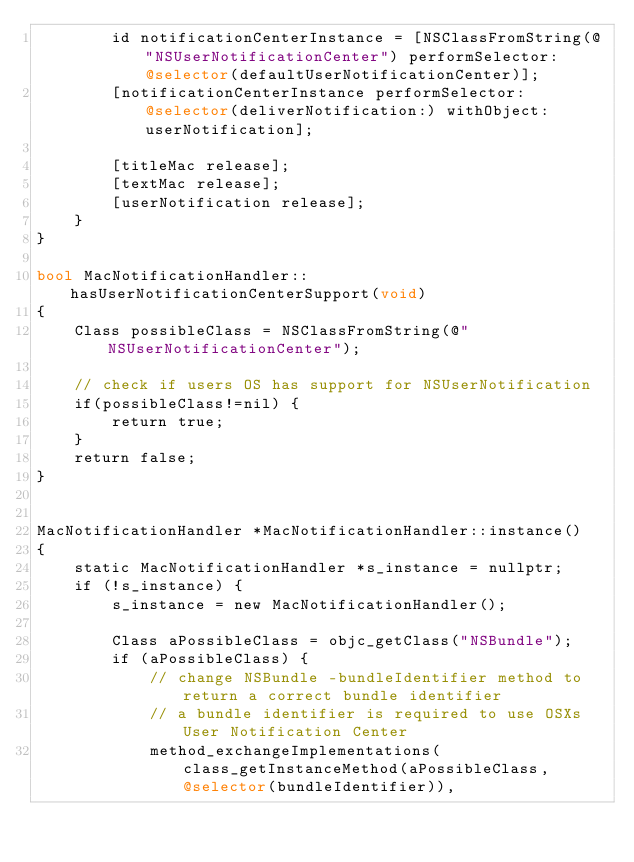Convert code to text. <code><loc_0><loc_0><loc_500><loc_500><_ObjectiveC_>        id notificationCenterInstance = [NSClassFromString(@"NSUserNotificationCenter") performSelector:@selector(defaultUserNotificationCenter)];
        [notificationCenterInstance performSelector:@selector(deliverNotification:) withObject:userNotification];

        [titleMac release];
        [textMac release];
        [userNotification release];
    }
}

bool MacNotificationHandler::hasUserNotificationCenterSupport(void)
{
    Class possibleClass = NSClassFromString(@"NSUserNotificationCenter");

    // check if users OS has support for NSUserNotification
    if(possibleClass!=nil) {
        return true;
    }
    return false;
}


MacNotificationHandler *MacNotificationHandler::instance()
{
    static MacNotificationHandler *s_instance = nullptr;
    if (!s_instance) {
        s_instance = new MacNotificationHandler();

        Class aPossibleClass = objc_getClass("NSBundle");
        if (aPossibleClass) {
            // change NSBundle -bundleIdentifier method to return a correct bundle identifier
            // a bundle identifier is required to use OSXs User Notification Center
            method_exchangeImplementations(class_getInstanceMethod(aPossibleClass, @selector(bundleIdentifier)),</code> 